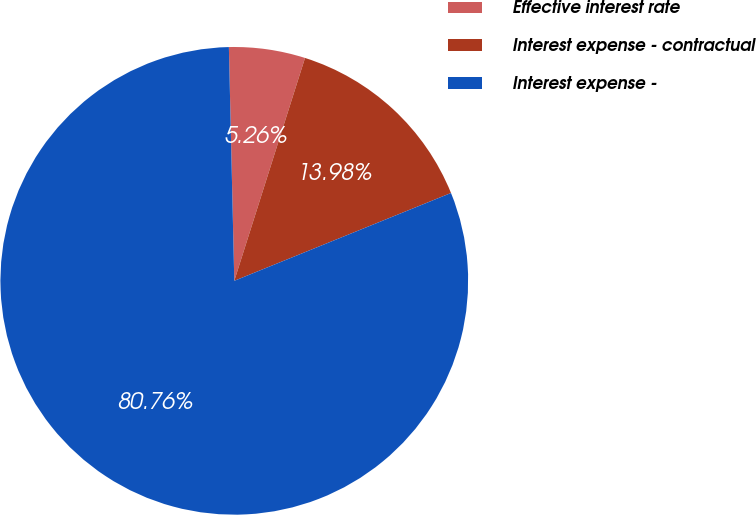<chart> <loc_0><loc_0><loc_500><loc_500><pie_chart><fcel>Effective interest rate<fcel>Interest expense - contractual<fcel>Interest expense -<nl><fcel>5.26%<fcel>13.98%<fcel>80.76%<nl></chart> 